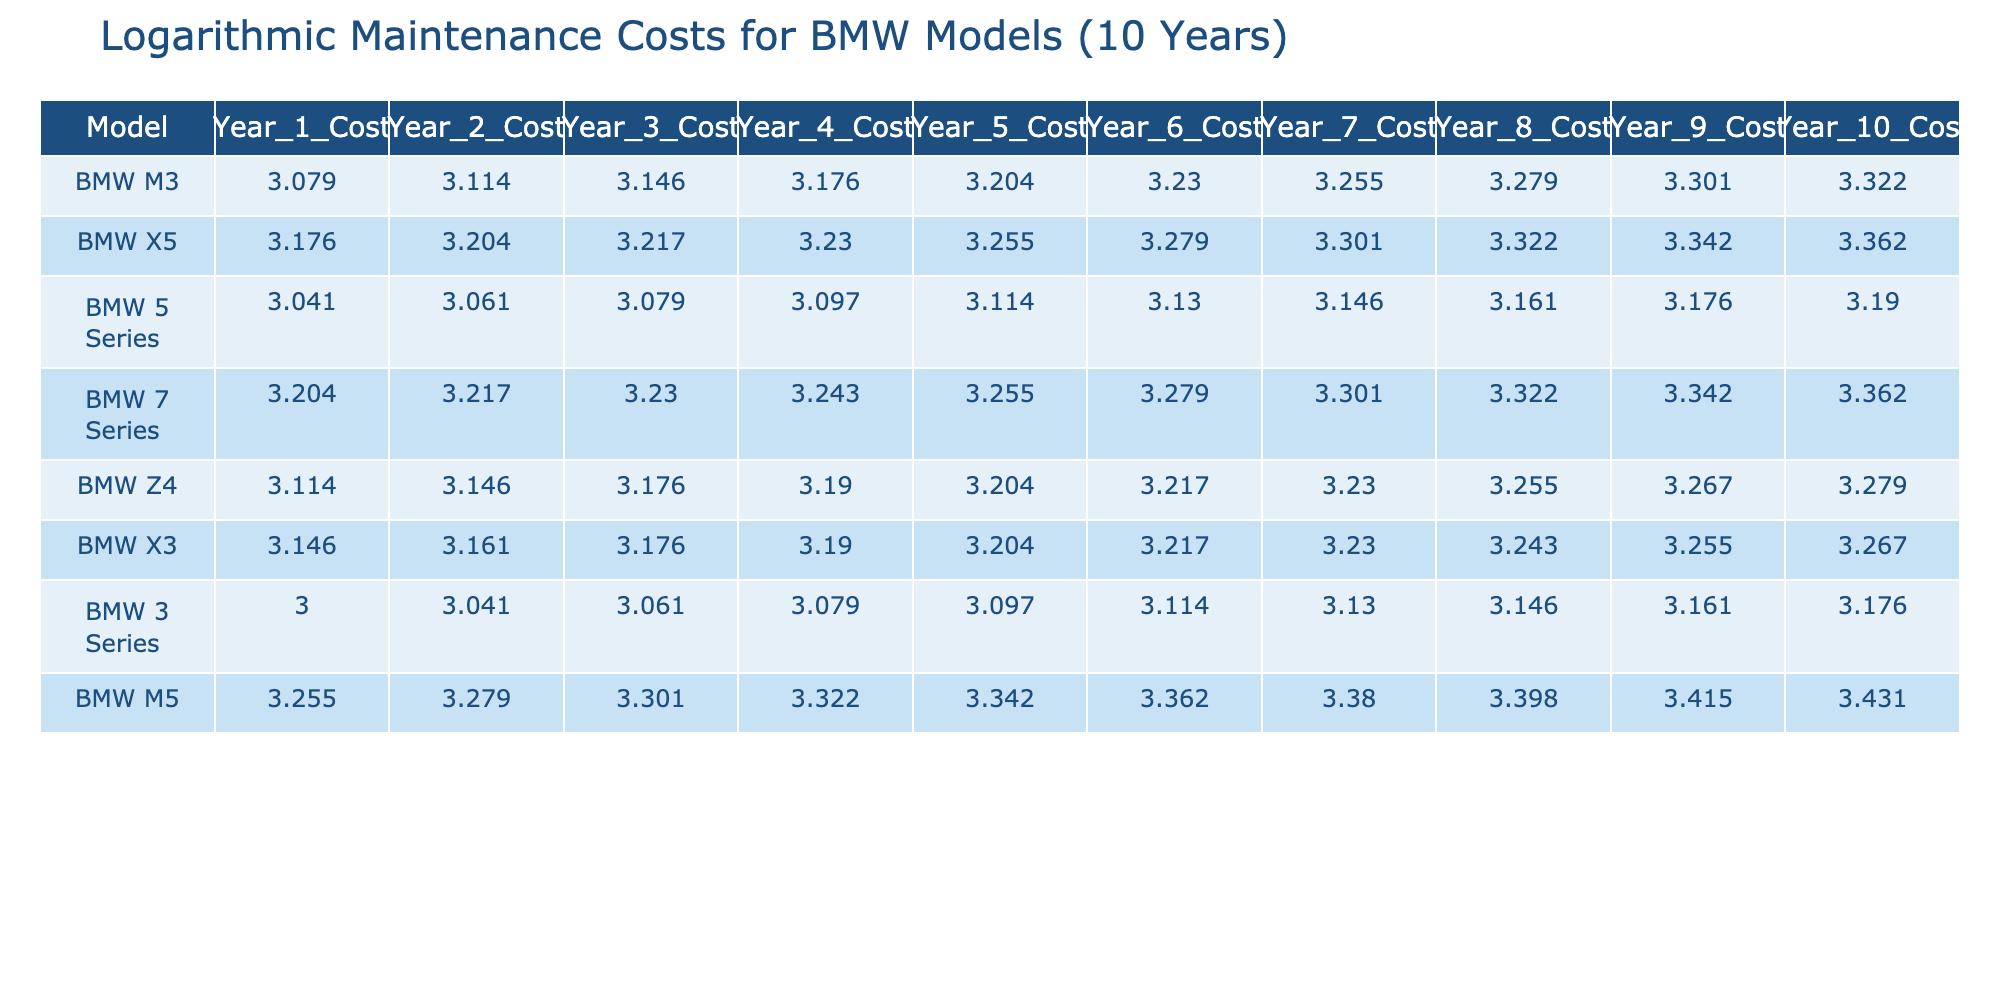What is the maintenance cost of the BMW M5 in year 10? The maintenance cost for the BMW M5 in year 10 is found directly in the table. For the model "BMW M5," the year 10 cost is listed as 2700.
Answer: 2700 Which BMW model has the highest maintenance cost in year 10? The table can be checked row by row for year 10 costs. The highest value in the year 10 column corresponds to the BMW M5, which has a cost of 2700.
Answer: BMW M5 What is the average maintenance cost of the BMW 7 Series over the 10-year period? To find the average, first sum the yearly costs of the BMW 7 Series: (1600 + 1650 + 1700 + 1750 + 1800 + 1900 + 2000 + 2100 + 2200 + 2300) = 18900. Then divide by 10: 18900/10 = 1890.
Answer: 1890 Did the maintenance cost for the BMW X5 increase every year? By reviewing the yearly costs for the BMW X5, the costs are: 1500, 1600, 1650, 1700, 1800, 1900, 2000, 2100, 2200, 2300. All values are increasing, confirming the statement is true.
Answer: Yes Which BMW model experienced the smallest maintenance cost increase from year 1 to year 2? The difference in costs from year 1 to year 2 for each model can be calculated. For the BMW 3 Series: 1100 - 1000 = 100, BMW 5 Series: 1150 - 1100 = 50, BMW M3: 1300 - 1200 = 100, and so on. The BMW 5 Series has the smallest increase of 50.
Answer: BMW 5 Series What is the total maintenance cost for the BMW X3 over 10 years? To find the total, add up all the maintenance costs for the BMW X3: (1400 + 1450 + 1500 + 1550 + 1600 + 1650 + 1700 + 1750 + 1800 + 1850) = 16400.
Answer: 16400 Is the average maintenance cost for BMW M models higher than that of the BMW 3 Series? Calculate the average for BMW M models (M3 and M5) and compare to the 3 Series. M3 average = (1200 + 1300 + 1400 + 1500 + 1600 + 1700 + 1800 + 1900 + 2000 + 2100) / 10 = 1650. M5 average = 2250. 3 Series average = (1000 + 1100 + 1150 + 1200 + 1250 + 1300 + 1350 + 1400 + 1450 + 1500) / 10 = 1250. M models average = (1650 + 2250) / 2 = 1950. Since 1950 > 1250, the statement is true.
Answer: Yes 